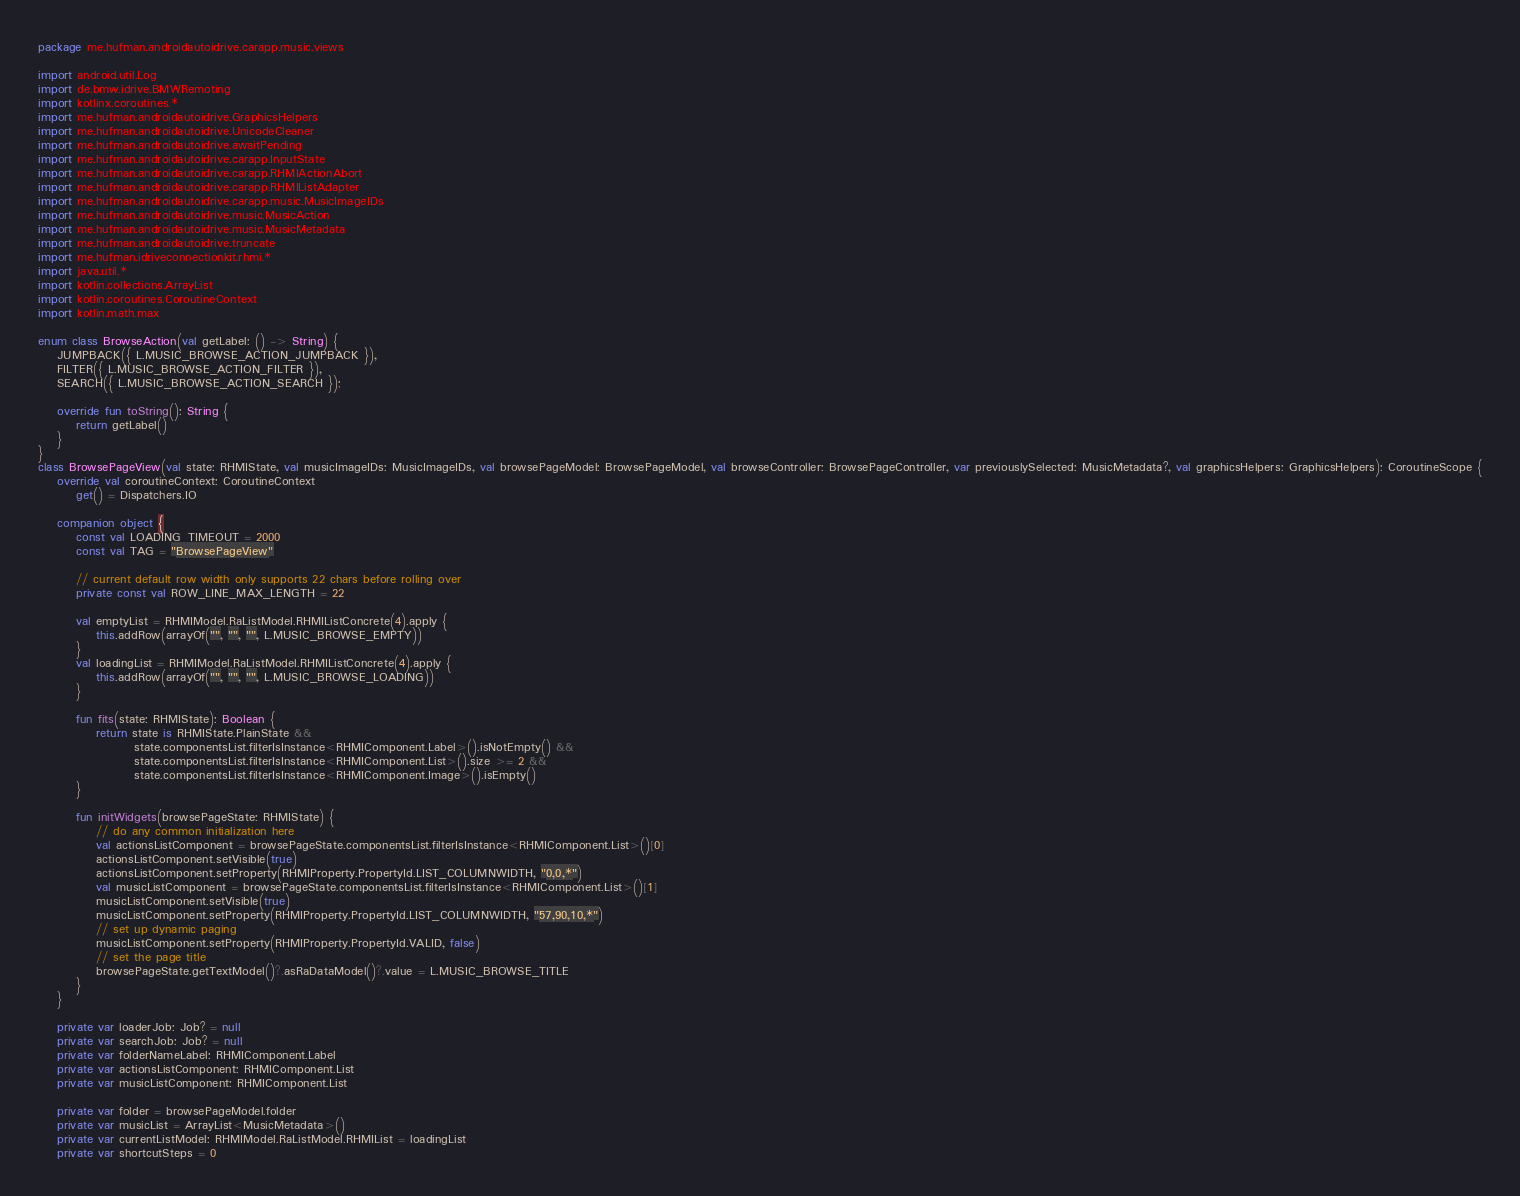Convert code to text. <code><loc_0><loc_0><loc_500><loc_500><_Kotlin_>package me.hufman.androidautoidrive.carapp.music.views

import android.util.Log
import de.bmw.idrive.BMWRemoting
import kotlinx.coroutines.*
import me.hufman.androidautoidrive.GraphicsHelpers
import me.hufman.androidautoidrive.UnicodeCleaner
import me.hufman.androidautoidrive.awaitPending
import me.hufman.androidautoidrive.carapp.InputState
import me.hufman.androidautoidrive.carapp.RHMIActionAbort
import me.hufman.androidautoidrive.carapp.RHMIListAdapter
import me.hufman.androidautoidrive.carapp.music.MusicImageIDs
import me.hufman.androidautoidrive.music.MusicAction
import me.hufman.androidautoidrive.music.MusicMetadata
import me.hufman.androidautoidrive.truncate
import me.hufman.idriveconnectionkit.rhmi.*
import java.util.*
import kotlin.collections.ArrayList
import kotlin.coroutines.CoroutineContext
import kotlin.math.max

enum class BrowseAction(val getLabel: () -> String) {
	JUMPBACK({ L.MUSIC_BROWSE_ACTION_JUMPBACK }),
	FILTER({ L.MUSIC_BROWSE_ACTION_FILTER }),
	SEARCH({ L.MUSIC_BROWSE_ACTION_SEARCH });

	override fun toString(): String {
		return getLabel()
	}
}
class BrowsePageView(val state: RHMIState, val musicImageIDs: MusicImageIDs, val browsePageModel: BrowsePageModel, val browseController: BrowsePageController, var previouslySelected: MusicMetadata?, val graphicsHelpers: GraphicsHelpers): CoroutineScope {
	override val coroutineContext: CoroutineContext
		get() = Dispatchers.IO

	companion object {
		const val LOADING_TIMEOUT = 2000
		const val TAG = "BrowsePageView"

		// current default row width only supports 22 chars before rolling over
		private const val ROW_LINE_MAX_LENGTH = 22

		val emptyList = RHMIModel.RaListModel.RHMIListConcrete(4).apply {
			this.addRow(arrayOf("", "", "", L.MUSIC_BROWSE_EMPTY))
		}
		val loadingList = RHMIModel.RaListModel.RHMIListConcrete(4).apply {
			this.addRow(arrayOf("", "", "", L.MUSIC_BROWSE_LOADING))
		}

		fun fits(state: RHMIState): Boolean {
			return state is RHMIState.PlainState &&
					state.componentsList.filterIsInstance<RHMIComponent.Label>().isNotEmpty() &&
					state.componentsList.filterIsInstance<RHMIComponent.List>().size >= 2 &&
					state.componentsList.filterIsInstance<RHMIComponent.Image>().isEmpty()
		}

		fun initWidgets(browsePageState: RHMIState) {
			// do any common initialization here
			val actionsListComponent = browsePageState.componentsList.filterIsInstance<RHMIComponent.List>()[0]
			actionsListComponent.setVisible(true)
			actionsListComponent.setProperty(RHMIProperty.PropertyId.LIST_COLUMNWIDTH, "0,0,*")
			val musicListComponent = browsePageState.componentsList.filterIsInstance<RHMIComponent.List>()[1]
			musicListComponent.setVisible(true)
			musicListComponent.setProperty(RHMIProperty.PropertyId.LIST_COLUMNWIDTH, "57,90,10,*")
			// set up dynamic paging
			musicListComponent.setProperty(RHMIProperty.PropertyId.VALID, false)
			// set the page title
			browsePageState.getTextModel()?.asRaDataModel()?.value = L.MUSIC_BROWSE_TITLE
		}
	}

	private var loaderJob: Job? = null
	private var searchJob: Job? = null
	private var folderNameLabel: RHMIComponent.Label
	private var actionsListComponent: RHMIComponent.List
	private var musicListComponent: RHMIComponent.List

	private var folder = browsePageModel.folder
	private var musicList = ArrayList<MusicMetadata>()
	private var currentListModel: RHMIModel.RaListModel.RHMIList = loadingList
	private var shortcutSteps = 0
</code> 